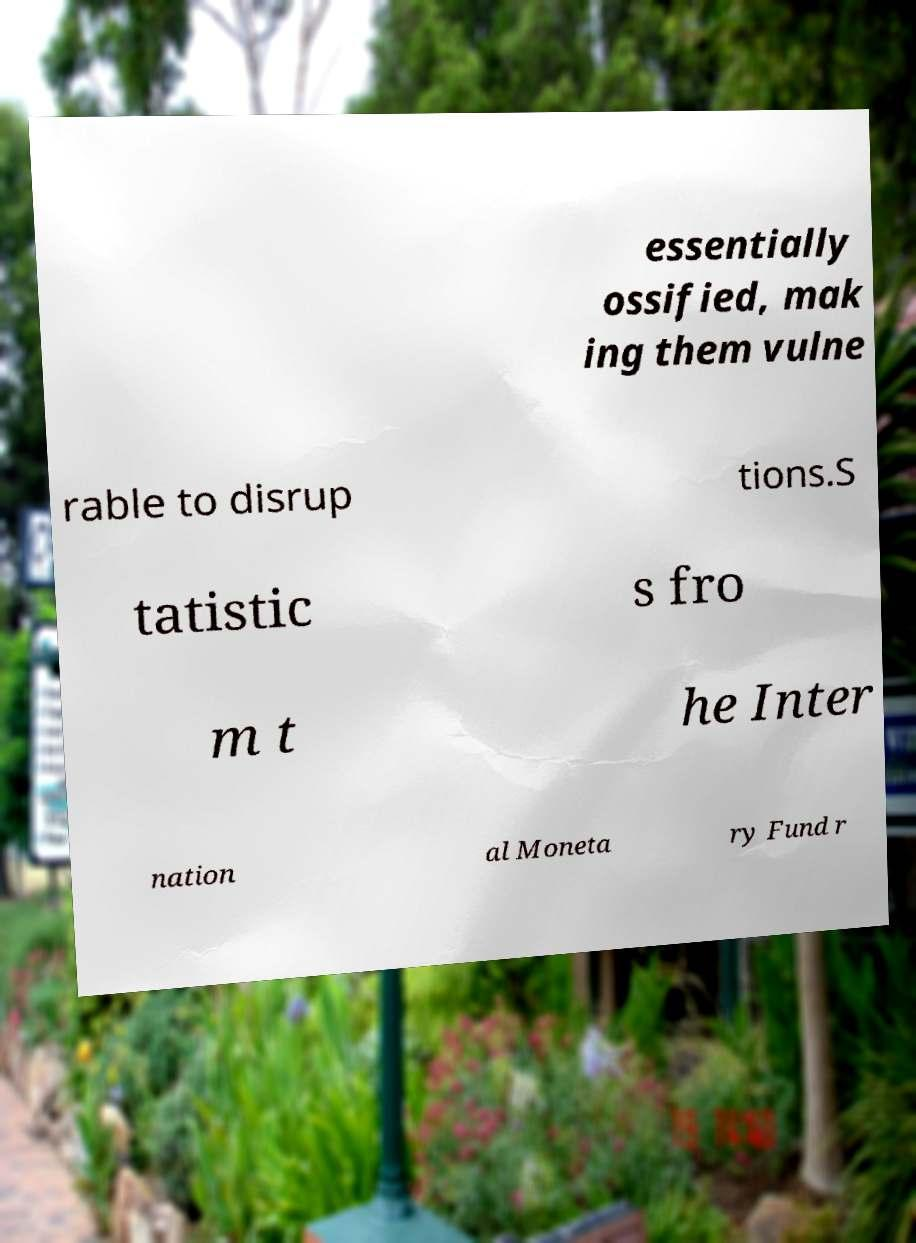Could you assist in decoding the text presented in this image and type it out clearly? essentially ossified, mak ing them vulne rable to disrup tions.S tatistic s fro m t he Inter nation al Moneta ry Fund r 